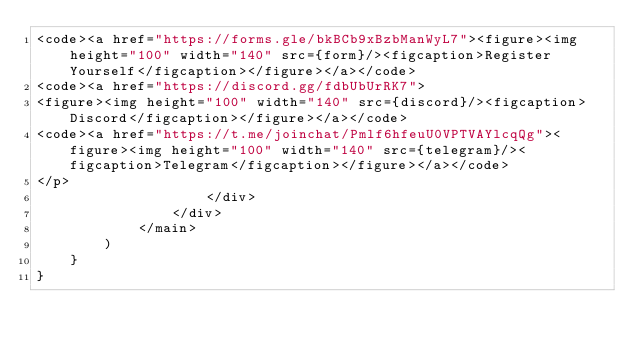<code> <loc_0><loc_0><loc_500><loc_500><_JavaScript_><code><a href="https://forms.gle/bkBCb9xBzbManWyL7"><figure><img height="100" width="140" src={form}/><figcaption>Register Yourself</figcaption></figure></a></code>
<code><a href="https://discord.gg/fdbUbUrRK7">
<figure><img height="100" width="140" src={discord}/><figcaption>Discord</figcaption></figure></a></code>
<code><a href="https://t.me/joinchat/Pmlf6hfeuU0VPTVAYlcqQg"><figure><img height="100" width="140" src={telegram}/><figcaption>Telegram</figcaption></figure></a></code>
</p>
                    </div>
                </div>
            </main>
        )
    }
}
</code> 